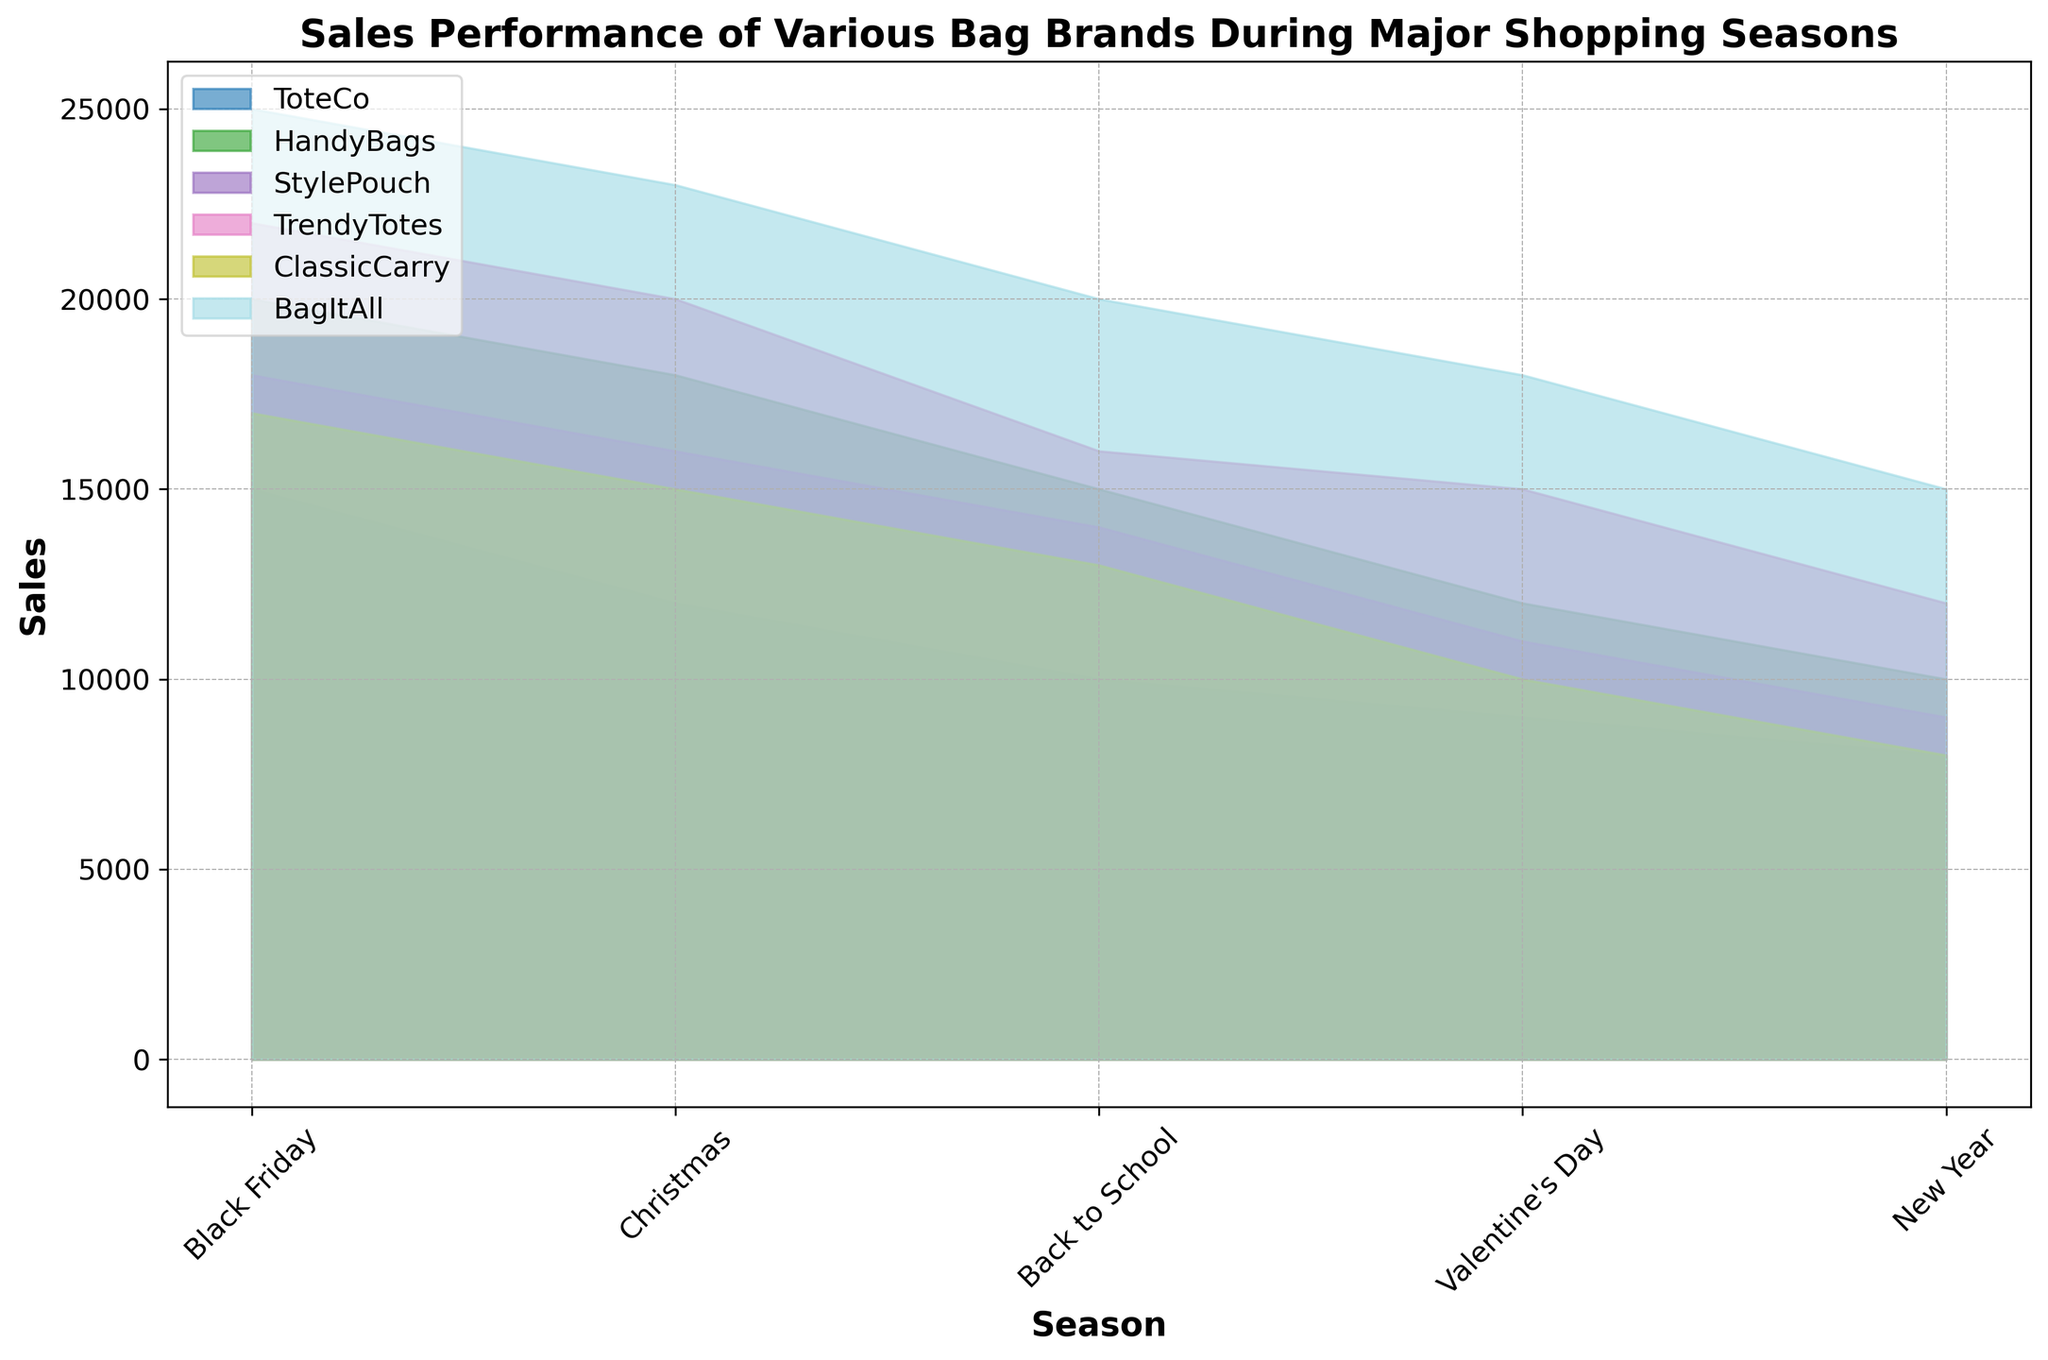Which brand had the highest sales during Black Friday? First, look at the section of the area chart corresponding to Black Friday. Then, identify which brand's area reaches the highest point.
Answer: BagItAll Between HandyBags and StylePouch, which brand had higher sales during Christmas? Refer to the Christmas section and compare the heights of the areas corresponding to HandyBags and StylePouch. HandyBags has a higher area height.
Answer: HandyBags What is the combined sales for ToteCo during Christmas and Valentine's Day? Look at the heights of ToteCo's areas during Christmas and Valentine's Day. ToteCo has sales of 12,000 during Christmas and 9,000 during Valentine's Day. Add these values. 12,000 + 9,000 = 21,000
Answer: 21,000 Which brand experienced the steepest decline in sales from Black Friday to New Year? Examine the trend lines for each brand's sales from Black Friday to New Year. Identify the brand whose line shows the most significant downward slope.
Answer: BagItAll On average, how many sales did ClassicCarry make across the given seasons? Sum the sales values for ClassicCarry across all seasons: 17,000 + 15,000 + 13,000 + 10,000 + 8,000 = 63,000. Then, divide by the number of seasons (5). 63,000 / 5 = 12,600
Answer: 12,600 During which season did TrendyTotes have their lowest sales? Check the areas of TrendyTotes across all seasons and find the season where its area height is the shortest.
Answer: New Year By how much did sales for BagItAll decrease from Christmas to New Year? Subtract the New Year sales (15,000) from the Christmas sales (23,000). 23,000 - 15,000 = 8,000
Answer: 8,000 Which brand has the most consistent sales performance indicated by the least variation across the seasons? Assess the fluctuation in sales for each brand across all seasons. The brand with the smallest differences between the highest and lowest sales values is the most consistent.
Answer: StylePouch 